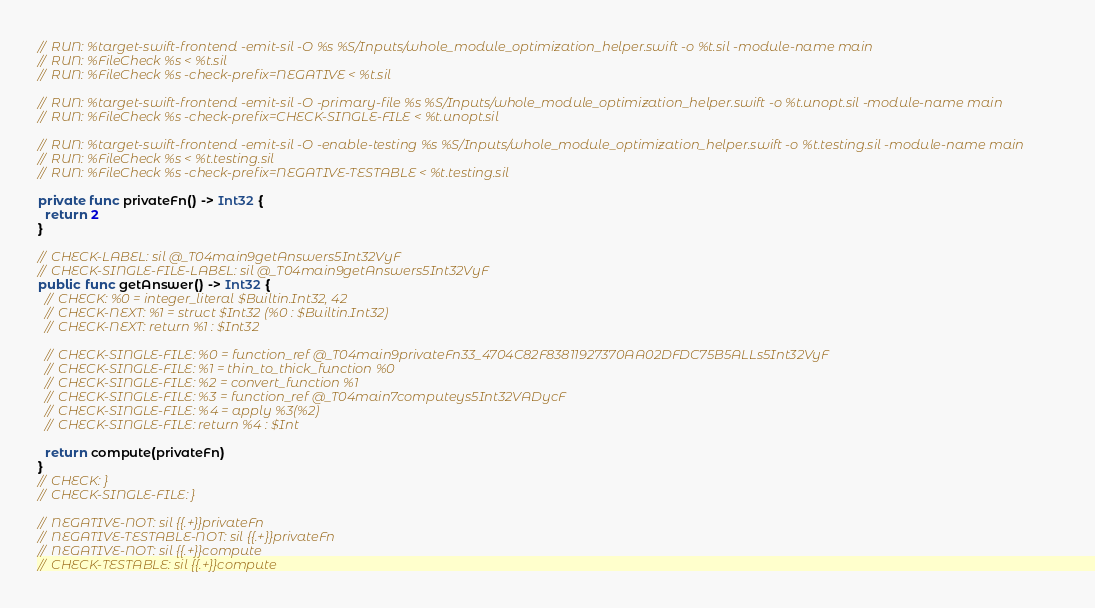Convert code to text. <code><loc_0><loc_0><loc_500><loc_500><_Swift_>// RUN: %target-swift-frontend -emit-sil -O %s %S/Inputs/whole_module_optimization_helper.swift -o %t.sil -module-name main
// RUN: %FileCheck %s < %t.sil
// RUN: %FileCheck %s -check-prefix=NEGATIVE < %t.sil

// RUN: %target-swift-frontend -emit-sil -O -primary-file %s %S/Inputs/whole_module_optimization_helper.swift -o %t.unopt.sil -module-name main
// RUN: %FileCheck %s -check-prefix=CHECK-SINGLE-FILE < %t.unopt.sil

// RUN: %target-swift-frontend -emit-sil -O -enable-testing %s %S/Inputs/whole_module_optimization_helper.swift -o %t.testing.sil -module-name main
// RUN: %FileCheck %s < %t.testing.sil
// RUN: %FileCheck %s -check-prefix=NEGATIVE-TESTABLE < %t.testing.sil

private func privateFn() -> Int32 {
  return 2
}

// CHECK-LABEL: sil @_T04main9getAnswers5Int32VyF
// CHECK-SINGLE-FILE-LABEL: sil @_T04main9getAnswers5Int32VyF
public func getAnswer() -> Int32 {
  // CHECK: %0 = integer_literal $Builtin.Int32, 42
  // CHECK-NEXT: %1 = struct $Int32 (%0 : $Builtin.Int32)
  // CHECK-NEXT: return %1 : $Int32

  // CHECK-SINGLE-FILE: %0 = function_ref @_T04main9privateFn33_4704C82F83811927370AA02DFDC75B5ALLs5Int32VyF
  // CHECK-SINGLE-FILE: %1 = thin_to_thick_function %0
  // CHECK-SINGLE-FILE: %2 = convert_function %1
  // CHECK-SINGLE-FILE: %3 = function_ref @_T04main7computeys5Int32VADycF
  // CHECK-SINGLE-FILE: %4 = apply %3(%2)
  // CHECK-SINGLE-FILE: return %4 : $Int

  return compute(privateFn)
}
// CHECK: }
// CHECK-SINGLE-FILE: }

// NEGATIVE-NOT: sil {{.+}}privateFn
// NEGATIVE-TESTABLE-NOT: sil {{.+}}privateFn
// NEGATIVE-NOT: sil {{.+}}compute
// CHECK-TESTABLE: sil {{.+}}compute
</code> 